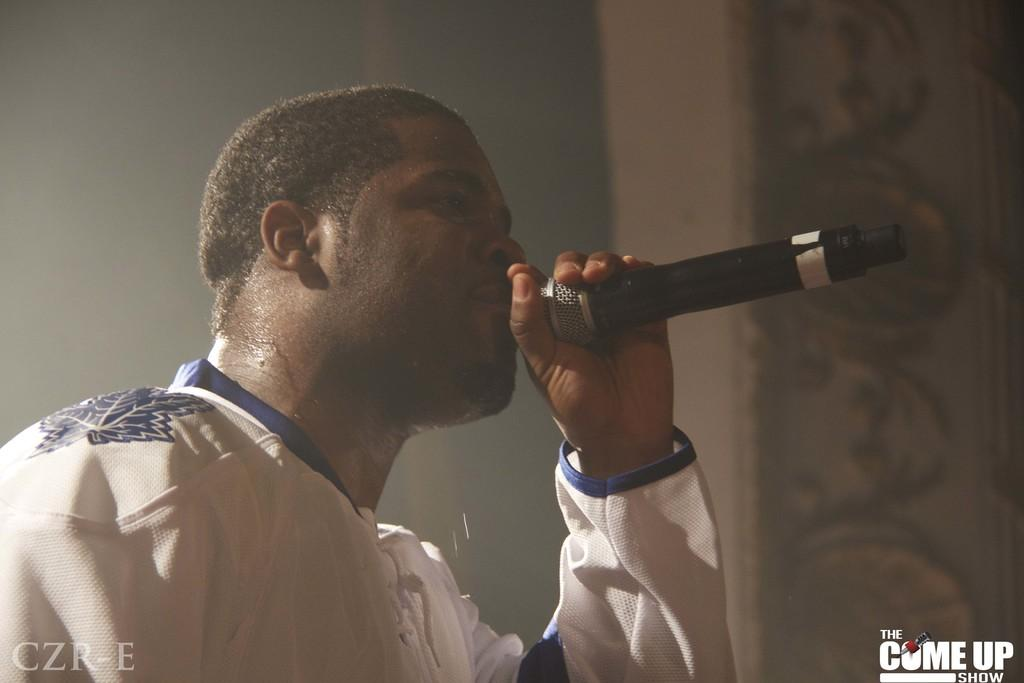Who is the main subject in the image? There is a man in the image. What is the man holding in the image? The man is holding a microphone. Can you describe the background of the image? The background of the image is blurred. Are there any additional features on the image itself? Yes, there are watermarks on the image. What type of fiction is the man reading from the shelf in the image? There is no shelf or fiction present in the image; it features a man holding a microphone with a blurred background and watermarks. 